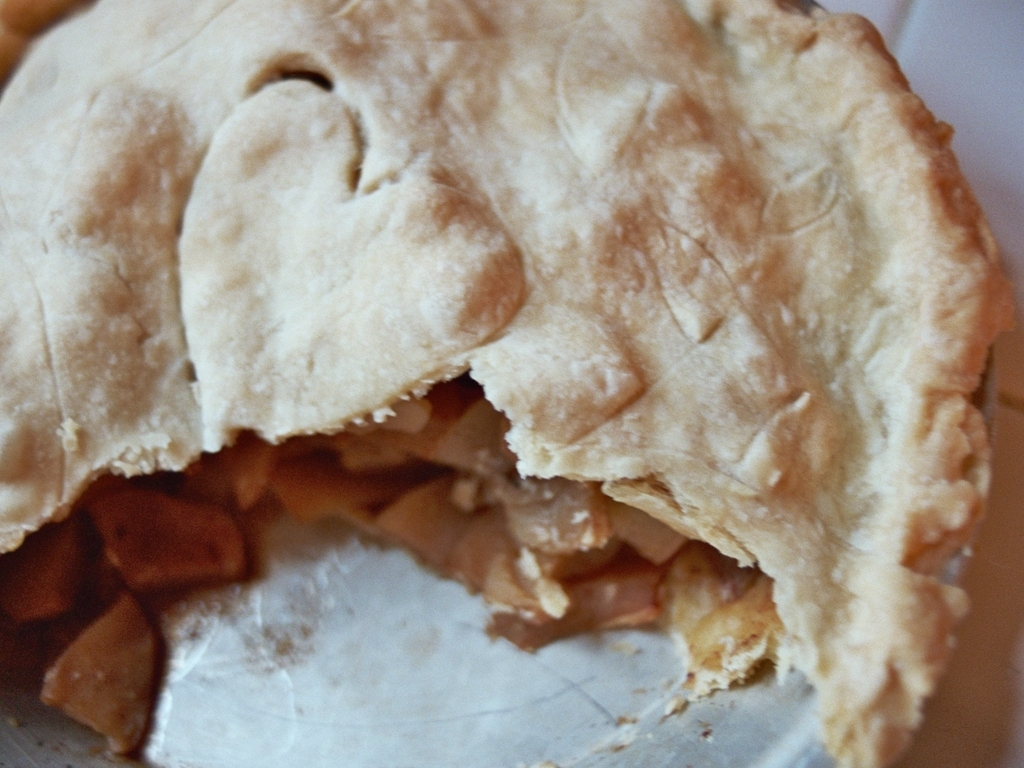What type of pie is shown in this image? The image displays a pie that appears to have a fruit filling, possibly apple, given the texture and color of the filling. However, without a clearer view or additional information, it's not possible to determine the exact type with certainty. Is this pie freshly baked or store-bought? While it is challenging to determine from the image alone, certain indicators suggest it might be homemade. These include the slightly irregular crust and the natural look of the filling. Store-bought pies often have a more uniform appearance. 